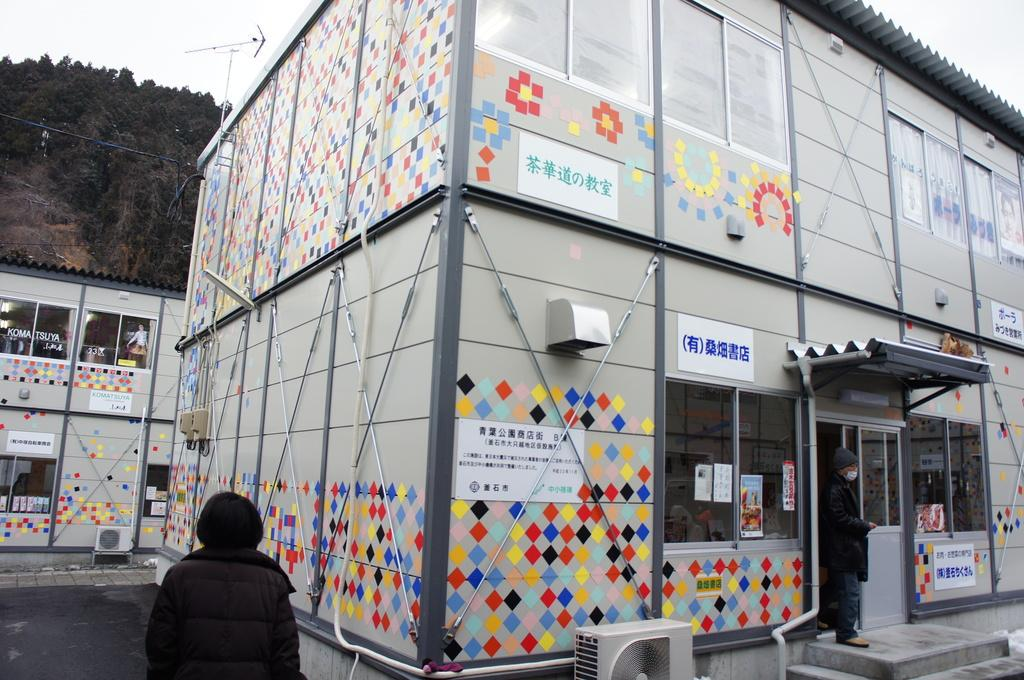What is located on the right side of the image? There is a person standing and an air conditioning unit (AC) on the right side of the image. What is located on the left side of the image? There is another person on the left side of the image. What can be seen in the background of the image? There are buildings and trees in the background of the image. How many books are visible on the person's head in the image? There are no books visible on anyone's head in the image. What day of the week is depicted in the image? The day of the week is not mentioned or depicted in the image. 